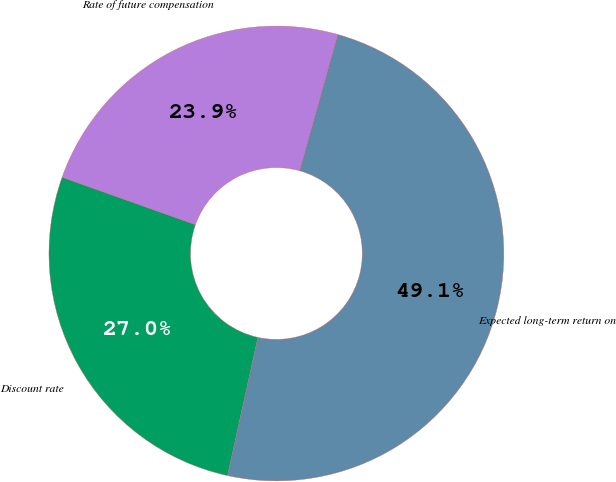Convert chart to OTSL. <chart><loc_0><loc_0><loc_500><loc_500><pie_chart><fcel>Discount rate<fcel>Expected long-term return on<fcel>Rate of future compensation<nl><fcel>26.99%<fcel>49.1%<fcel>23.91%<nl></chart> 